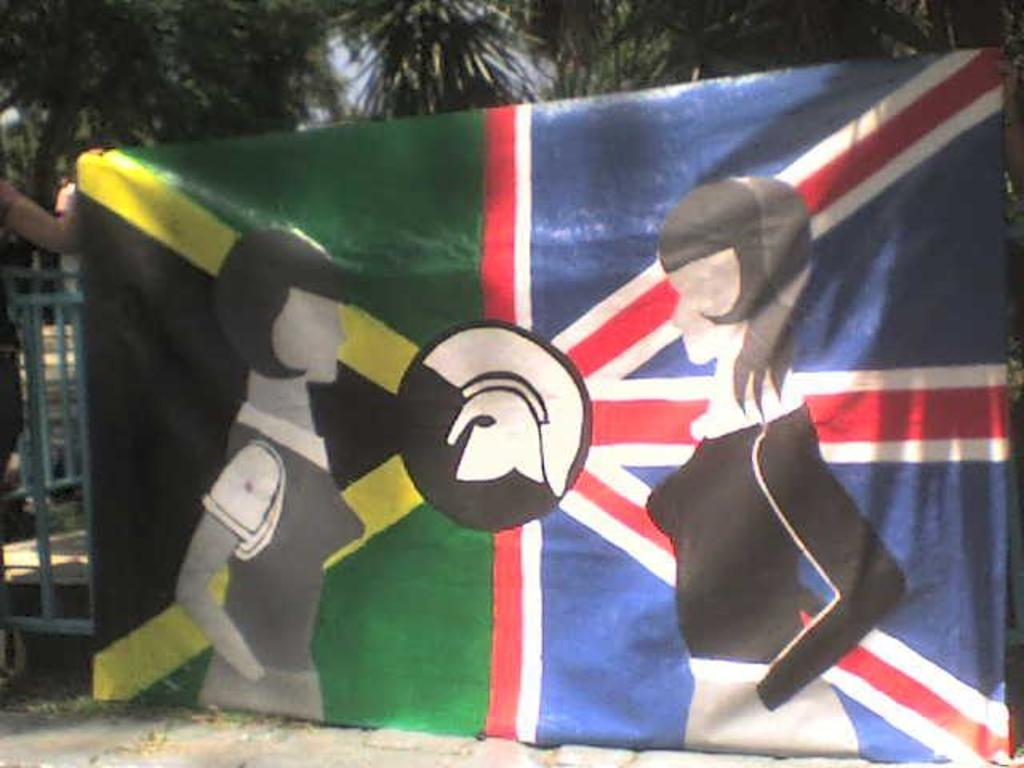What is the main subject in the middle of the image? There is a flag in the middle of the image. What is depicted on the flag? The flag has pictures of two girls. What can be seen in the background of the image? There are trees in the background of the image. Who is holding the flag in the image? There is a person holding the flag on the left side of the image. What type of pain can be seen on the faces of the girls depicted on the flag? There is no indication of pain on the faces of the girls depicted on the flag; they appear to be smiling or neutral. What kind of quartz is used to make the flagpole in the image? There is no information about the material used for the flagpole in the image, and quartz is not mentioned. 